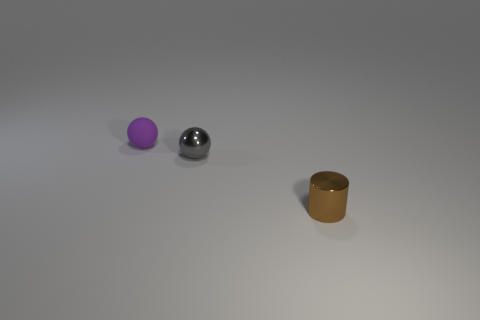Add 3 purple rubber balls. How many objects exist? 6 Subtract all spheres. How many objects are left? 1 Add 3 metal spheres. How many metal spheres are left? 4 Add 2 large red matte blocks. How many large red matte blocks exist? 2 Subtract 0 purple blocks. How many objects are left? 3 Subtract all small cubes. Subtract all spheres. How many objects are left? 1 